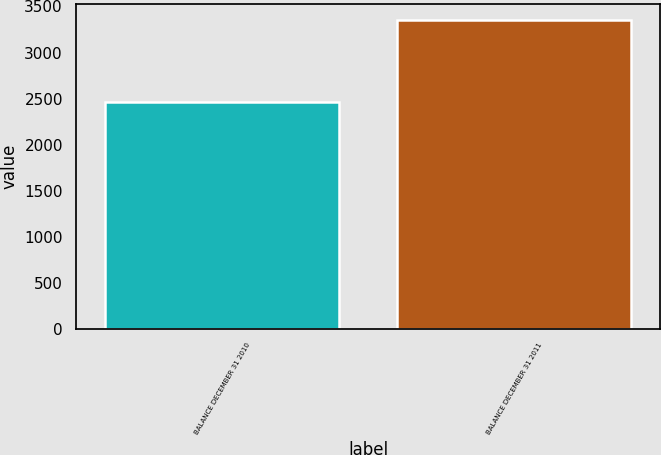Convert chart to OTSL. <chart><loc_0><loc_0><loc_500><loc_500><bar_chart><fcel>BALANCE DECEMBER 31 2010<fcel>BALANCE DECEMBER 31 2011<nl><fcel>2460<fcel>3355<nl></chart> 